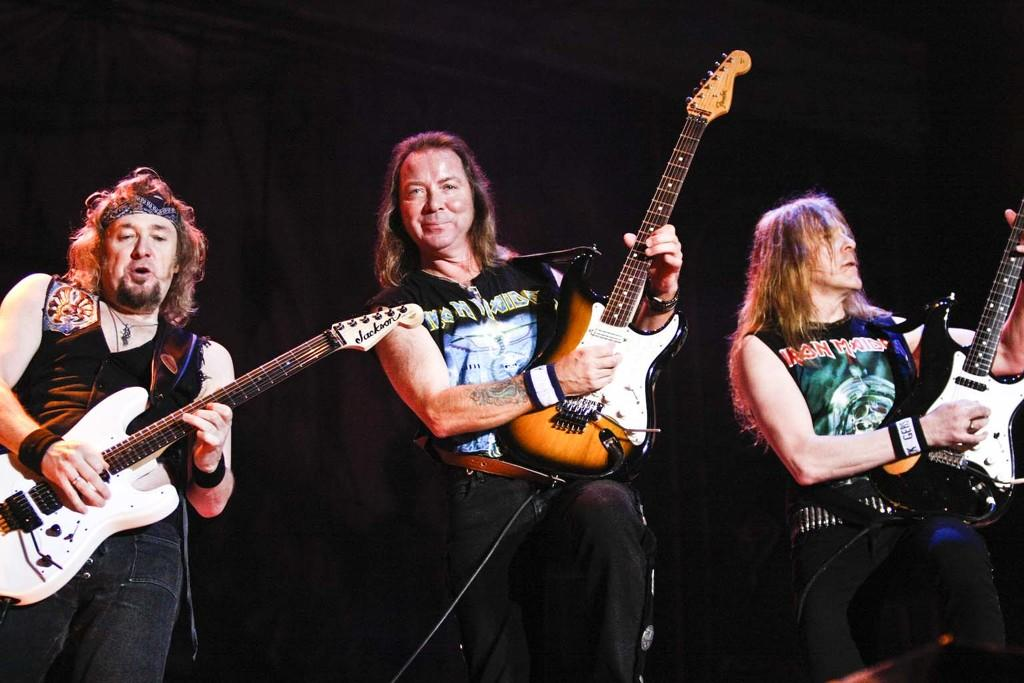How many people are in the image? There are three persons in the image. Where are the persons located in the image? The persons are standing on a stage. What are the persons holding in the image? Each person is holding a guitar. What are the persons wearing in the image? The persons are wearing black t-shirts. What type of sheet is visible on the stage in the image? There is no sheet visible on the stage in the image. Can you tell me how many bottles are being used by the persons in the image? There are no bottles present in the image; the persons are holding guitars. 